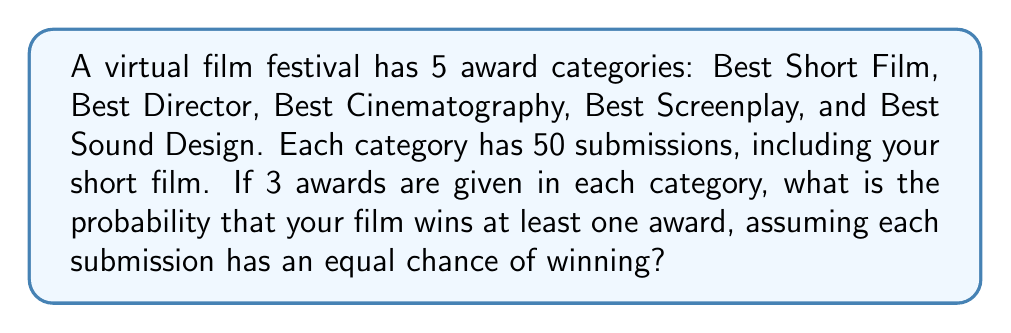Give your solution to this math problem. Let's approach this step-by-step:

1) First, let's calculate the probability of winning in a single category:
   $P(\text{winning in one category}) = \frac{3}{50} = \frac{3}{50}$

2) The probability of not winning in a single category is:
   $P(\text{not winning in one category}) = 1 - \frac{3}{50} = \frac{47}{50}$

3) Since your film is submitted to all 5 categories, to not win any award, you need to not win in all 5 categories. The probability of this is:
   $P(\text{not winning any award}) = (\frac{47}{50})^5$

4) Therefore, the probability of winning at least one award is the complement of not winning any award:
   $P(\text{winning at least one award}) = 1 - (\frac{47}{50})^5$

5) Let's calculate this:
   $$\begin{align*}
   P(\text{winning at least one award}) &= 1 - (\frac{47}{50})^5 \\
   &= 1 - (0.94)^5 \\
   &= 1 - 0.7351 \\
   &= 0.2649
   \end{align*}$$

6) Converting to a percentage:
   $0.2649 \times 100\% = 26.49\%$
Answer: $26.49\%$ 